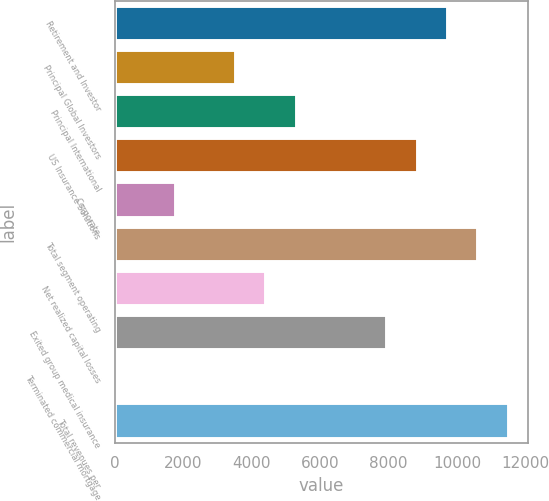Convert chart. <chart><loc_0><loc_0><loc_500><loc_500><bar_chart><fcel>Retirement and Investor<fcel>Principal Global Investors<fcel>Principal International<fcel>US Insurance Solutions<fcel>Corporate<fcel>Total segment operating<fcel>Net realized capital losses<fcel>Exited group medical insurance<fcel>Terminated commercial mortgage<fcel>Total revenues per<nl><fcel>9733.96<fcel>3539.94<fcel>5309.66<fcel>8849.1<fcel>1770.22<fcel>10618.8<fcel>4424.8<fcel>7964.24<fcel>0.5<fcel>11503.7<nl></chart> 